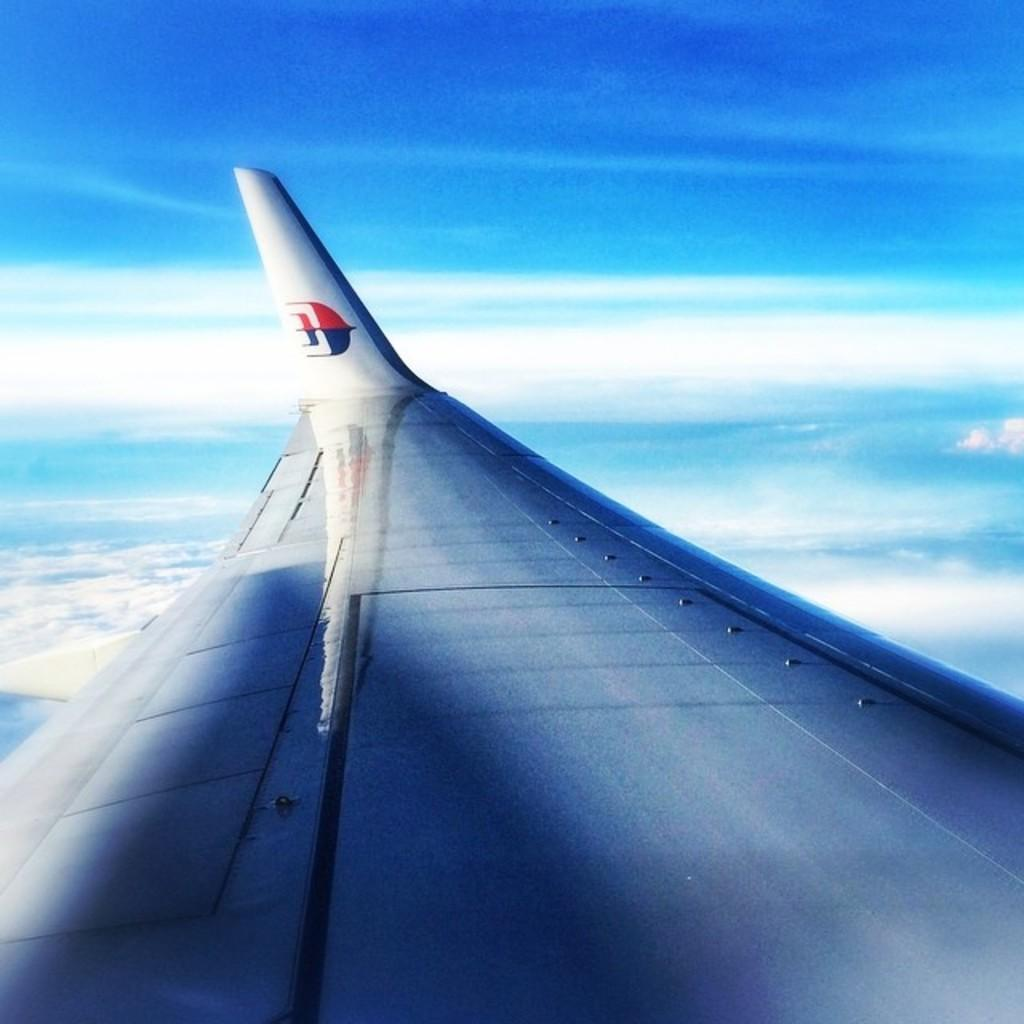What is the main subject of the image? There is a part of an aeroplane in the image. What can be seen in the background of the image? Clouds and the sky are visible in the image. What type of house does the friend live in, as seen in the image? There is no house or friend present in the image; it features a part of an aeroplane and clouds in the sky. 